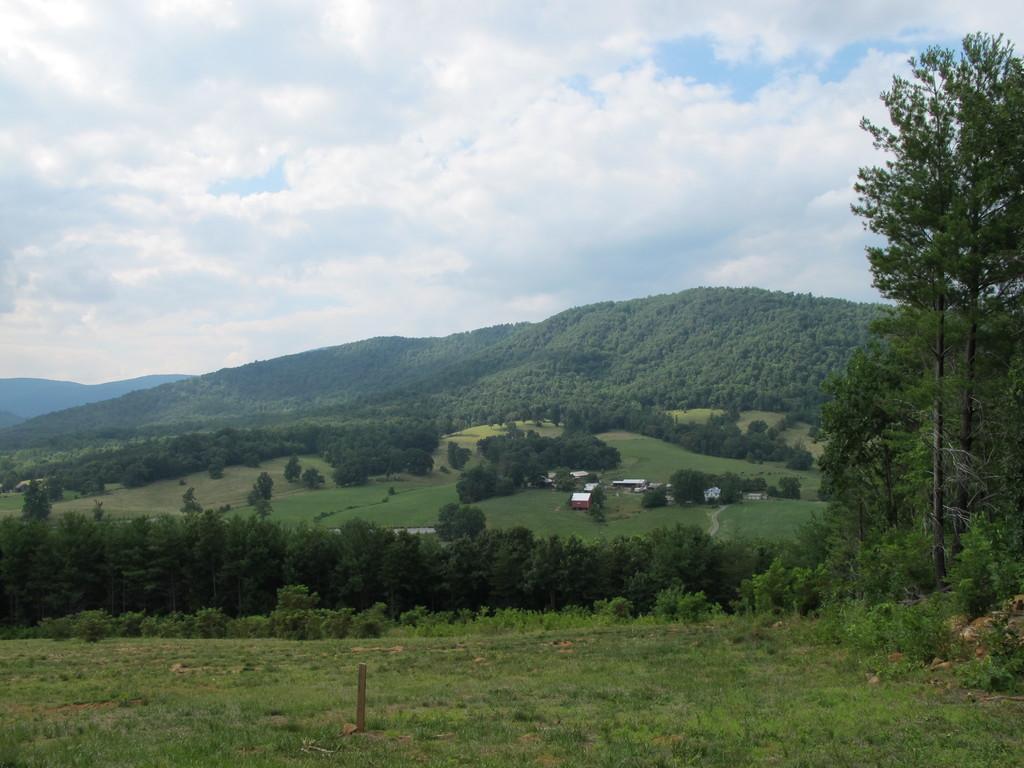Could you give a brief overview of what you see in this image? In this image there are hills and sky. We can see sheds. At the bottom there is grass and we can see plants. 